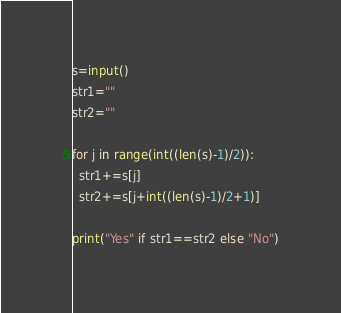<code> <loc_0><loc_0><loc_500><loc_500><_Python_>s=input()
str1=""
str2=""

for j in range(int((len(s)-1)/2)):
  str1+=s[j]
  str2+=s[j+int((len(s)-1)/2+1)]
    
print("Yes" if str1==str2 else "No")</code> 